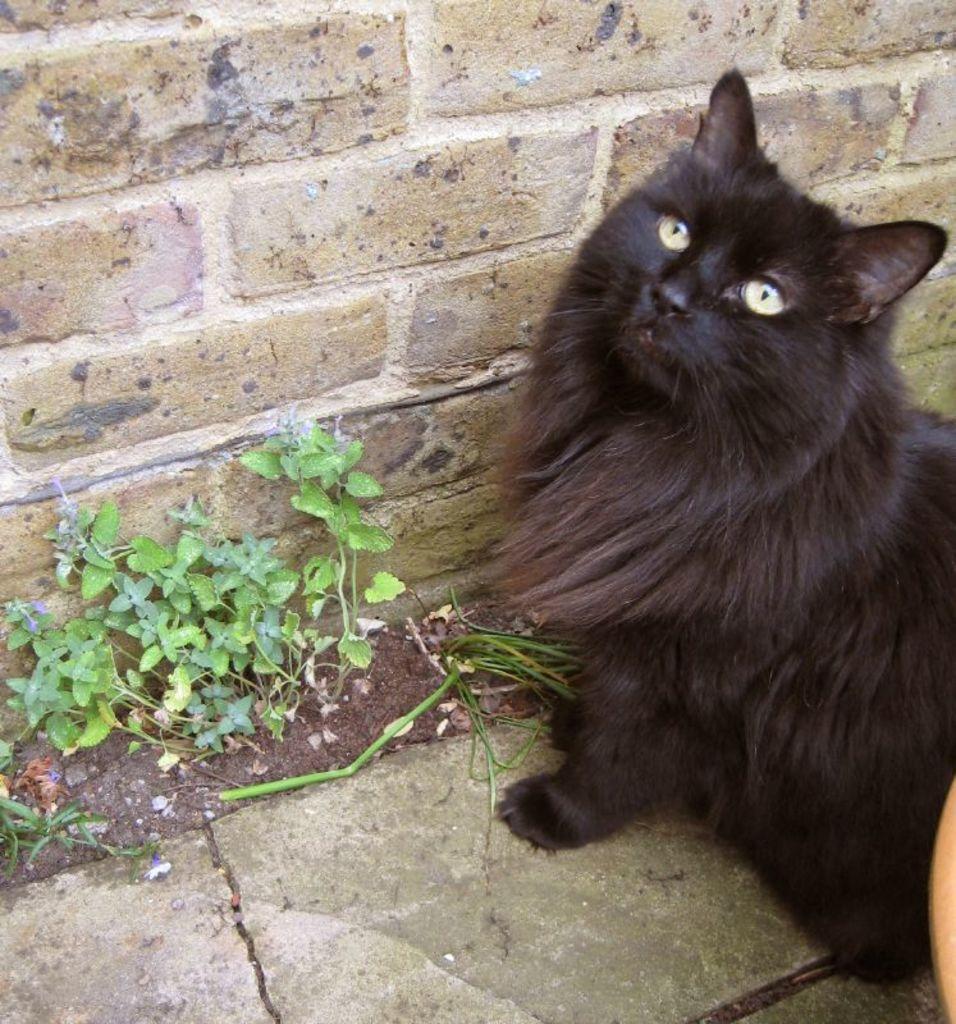Can you describe this image briefly? In the image there is a black cat and beside the black cat there are small plants and behind the plants there is a wall. 